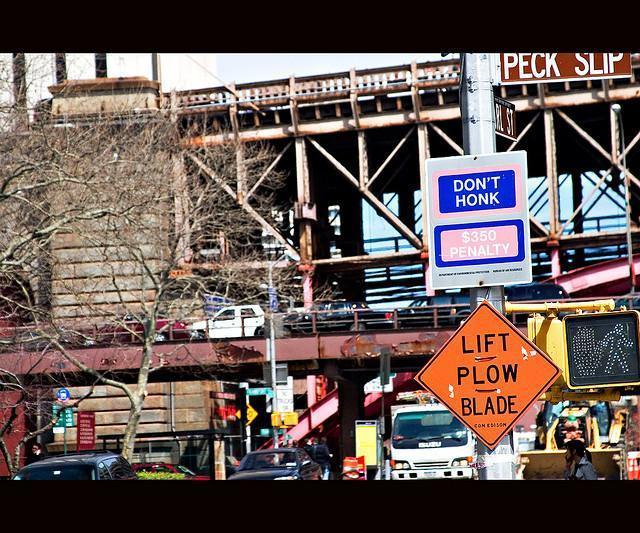How many cars are in the photo?
Give a very brief answer. 3. 